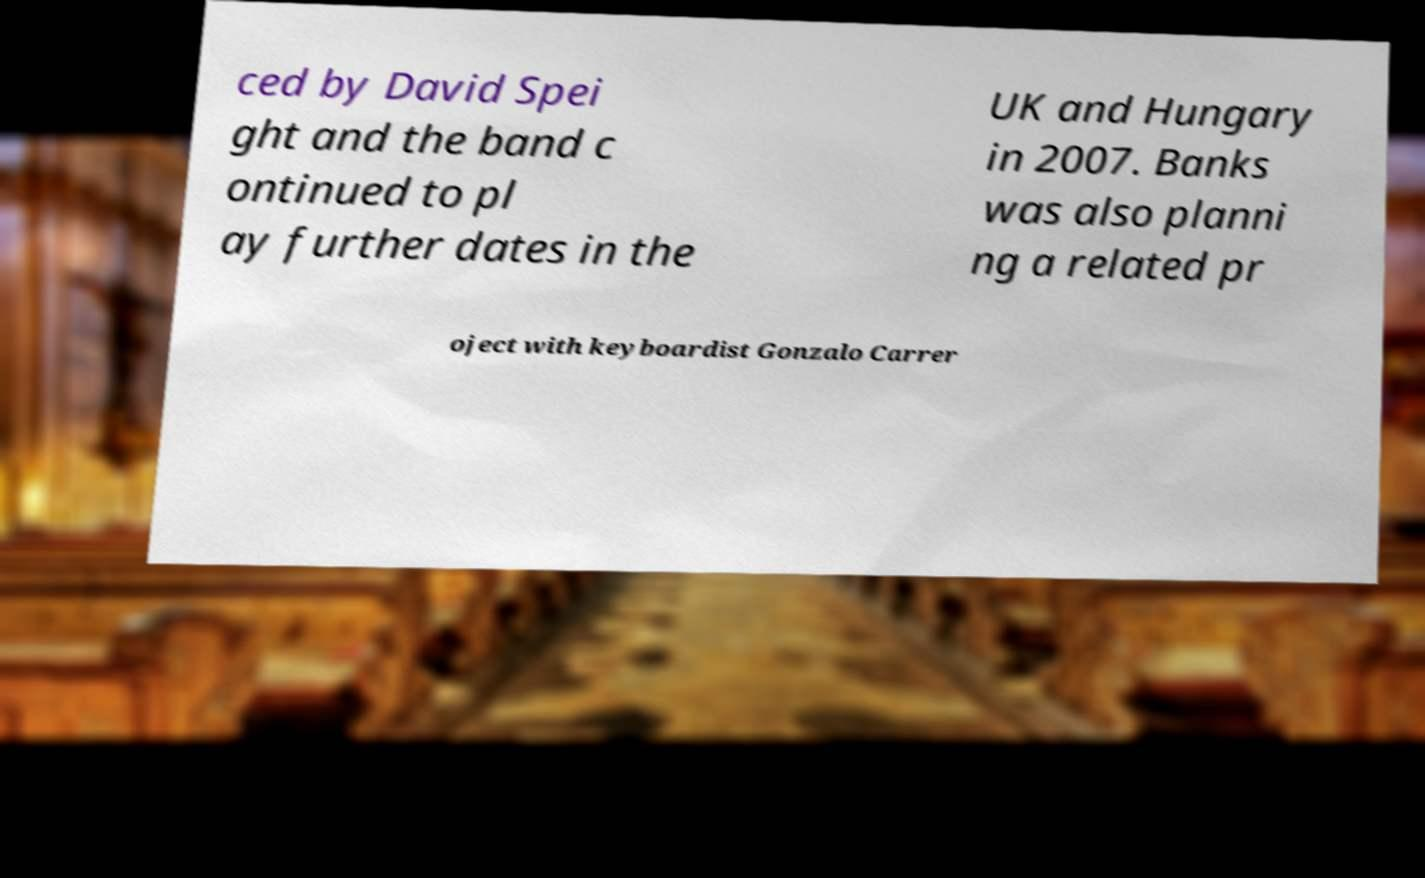Could you extract and type out the text from this image? ced by David Spei ght and the band c ontinued to pl ay further dates in the UK and Hungary in 2007. Banks was also planni ng a related pr oject with keyboardist Gonzalo Carrer 